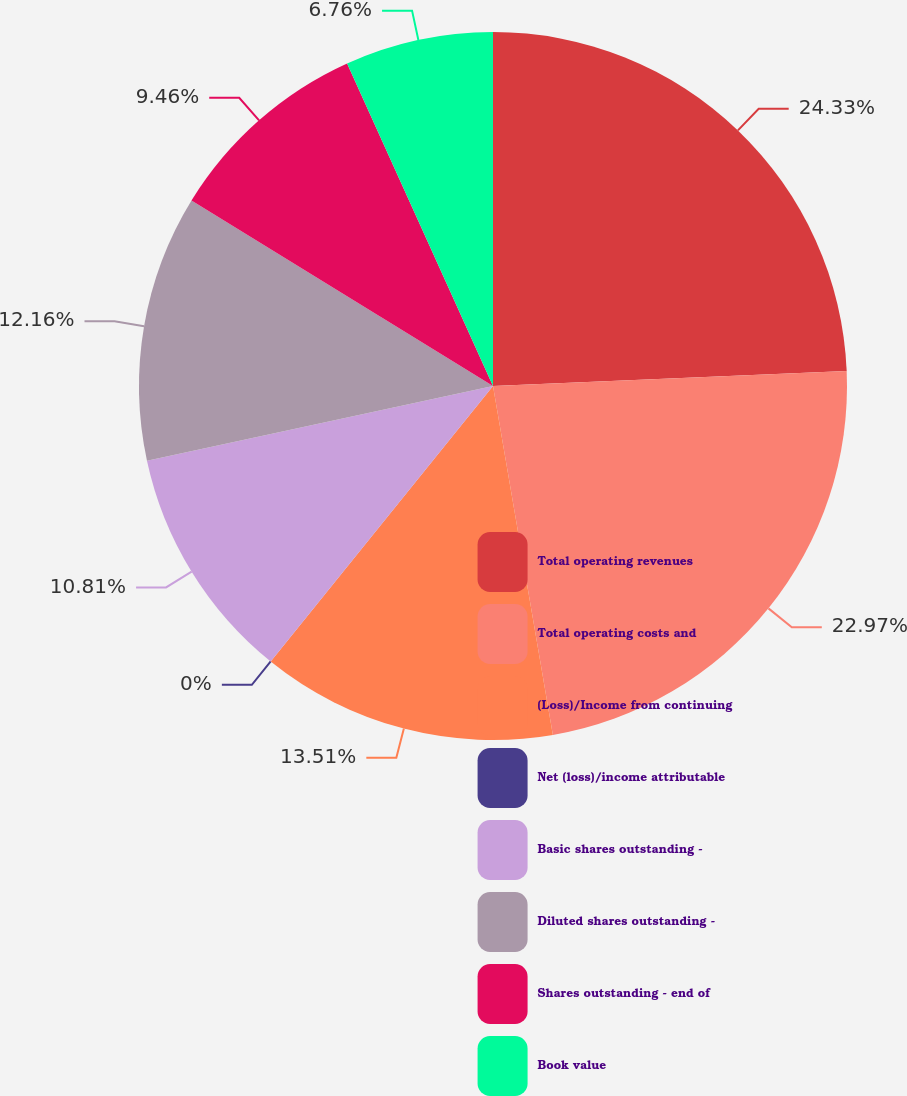<chart> <loc_0><loc_0><loc_500><loc_500><pie_chart><fcel>Total operating revenues<fcel>Total operating costs and<fcel>(Loss)/Income from continuing<fcel>Net (loss)/income attributable<fcel>Basic shares outstanding -<fcel>Diluted shares outstanding -<fcel>Shares outstanding - end of<fcel>Book value<nl><fcel>24.32%<fcel>22.97%<fcel>13.51%<fcel>0.0%<fcel>10.81%<fcel>12.16%<fcel>9.46%<fcel>6.76%<nl></chart> 